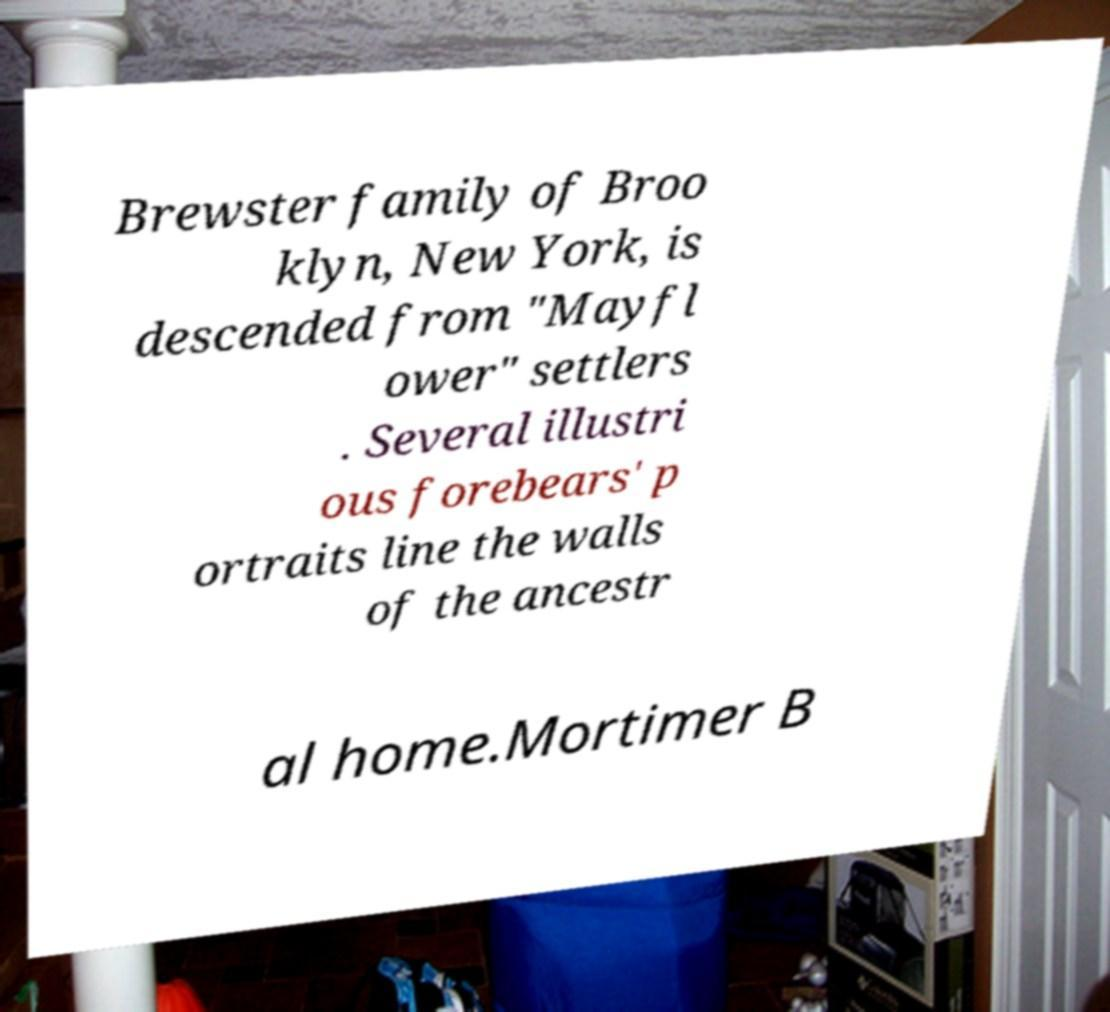Could you extract and type out the text from this image? Brewster family of Broo klyn, New York, is descended from "Mayfl ower" settlers . Several illustri ous forebears' p ortraits line the walls of the ancestr al home.Mortimer B 